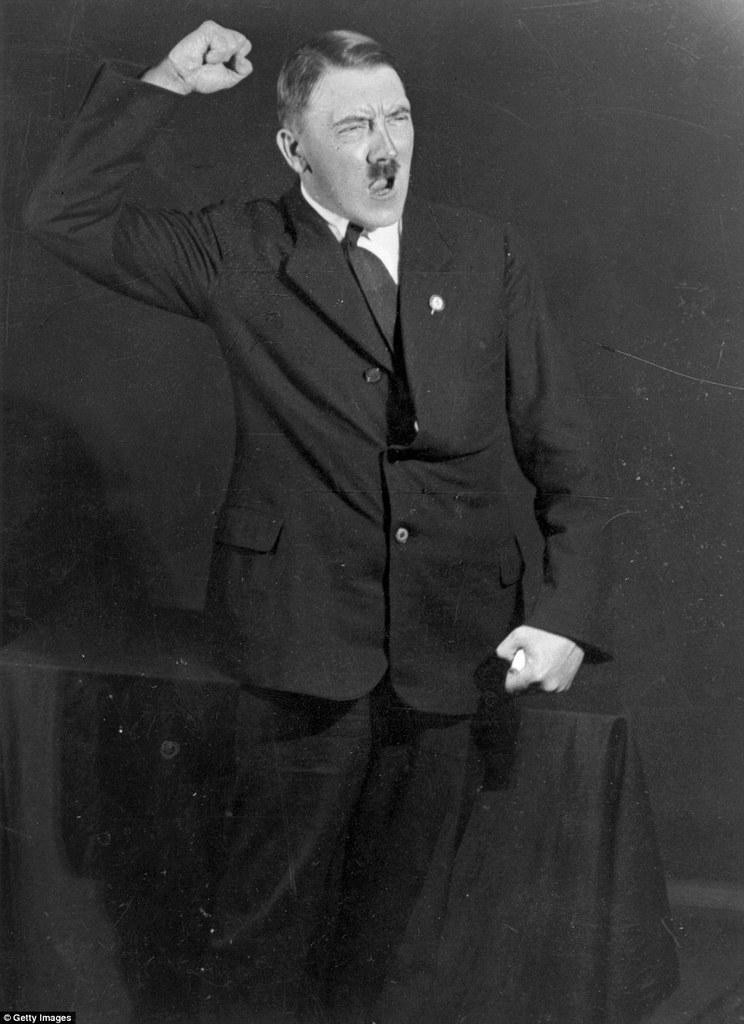What historical figure is depicted in the image? There is a depiction of Hitler in the image. What is Hitler doing in the image? Hitler is raising his hand in the image. What type of beam is being offered by Hitler in the image? There is no beam present in the image, and Hitler is not offering anything. 